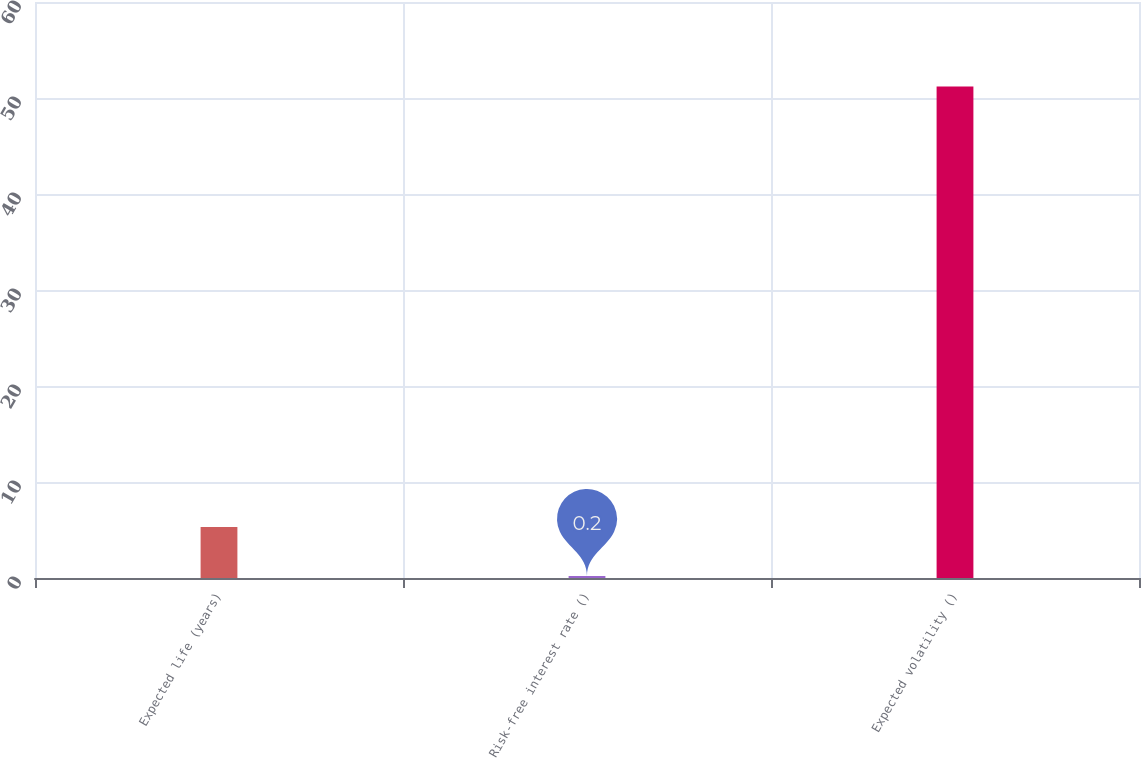Convert chart. <chart><loc_0><loc_0><loc_500><loc_500><bar_chart><fcel>Expected life (years)<fcel>Risk-free interest rate ()<fcel>Expected volatility ()<nl><fcel>5.3<fcel>0.2<fcel>51.2<nl></chart> 